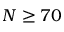<formula> <loc_0><loc_0><loc_500><loc_500>N \geq 7 0</formula> 